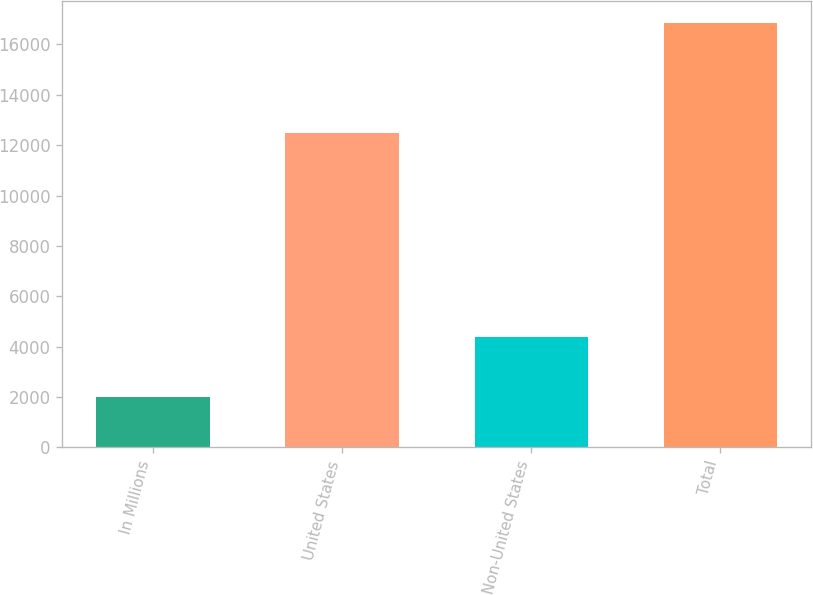<chart> <loc_0><loc_0><loc_500><loc_500><bar_chart><fcel>In Millions<fcel>United States<fcel>Non-United States<fcel>Total<nl><fcel>2019<fcel>12462.8<fcel>4402.4<fcel>16865.2<nl></chart> 